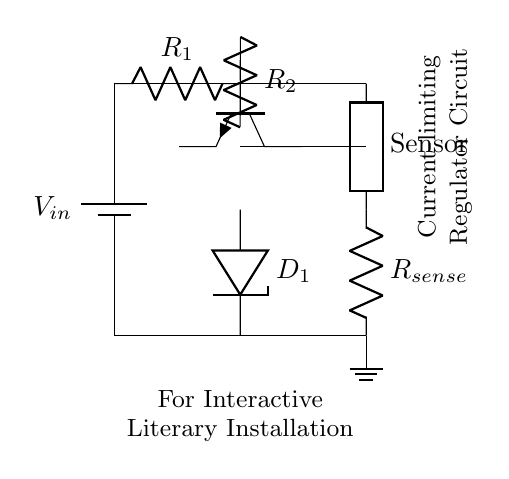What is the input voltage of this circuit? The input voltage is represented by the battery symbol labeled V_in. This indicates the source voltage that feeds into the circuit to power it.
Answer: V_in What component is used to sense current in this circuit? The component responsible for sensing current is labeled R_sense in the diagram. This resistor is placed in the circuit to help measure the current flowing to the load, which is essential for current-limiting.
Answer: R_sense How many resistors are present in this circuit? There are three resistors present in the diagram: R_1, R_2, and R_sense. Each of these plays a role in controlling voltage and current within the circuit.
Answer: 3 What type of transistor is used in this regulator circuit? The diagram indicates the use of an NPN transistor, which is represented by the npn symbol. This is a key component that helps regulate the output current based on the input current and feedback.
Answer: NPN Why is a Zener diode included in this circuit? The Zener diode, labeled D_1, is included to provide voltage regulation. It prevents the voltage from exceeding a certain level, protecting the attached sensor by ensuring that it operates within its safe limits.
Answer: Voltage regulation What is the primary function of this circuit? The primary function of this current-limiting regulator circuit is to protect delicate sensors from excessive current, ensuring that the interactive literary installation operates safely without damaging these components.
Answer: Protection What is the load connected to this regulator circuit? The load connected to this circuit is labeled as "Sensor." This indicates that the circuit is designed to supply power to sensitive sensor devices that may be part of the interactive installation.
Answer: Sensor 